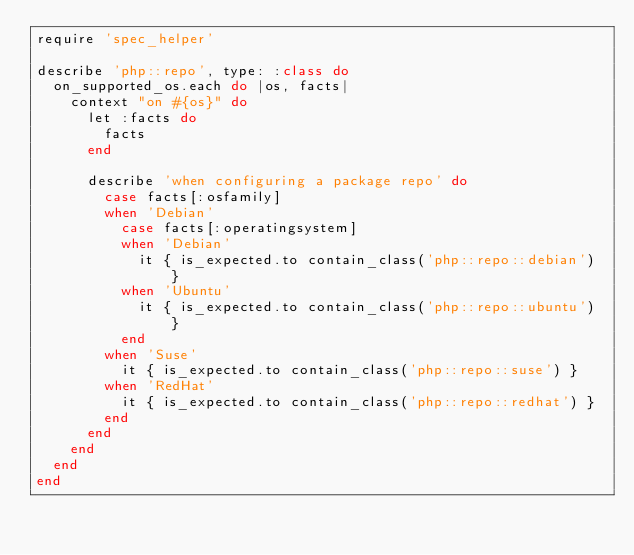Convert code to text. <code><loc_0><loc_0><loc_500><loc_500><_Ruby_>require 'spec_helper'

describe 'php::repo', type: :class do
  on_supported_os.each do |os, facts|
    context "on #{os}" do
      let :facts do
        facts
      end

      describe 'when configuring a package repo' do
        case facts[:osfamily]
        when 'Debian'
          case facts[:operatingsystem]
          when 'Debian'
            it { is_expected.to contain_class('php::repo::debian') }
          when 'Ubuntu'
            it { is_expected.to contain_class('php::repo::ubuntu') }
          end
        when 'Suse'
          it { is_expected.to contain_class('php::repo::suse') }
        when 'RedHat'
          it { is_expected.to contain_class('php::repo::redhat') }
        end
      end
    end
  end
end
</code> 